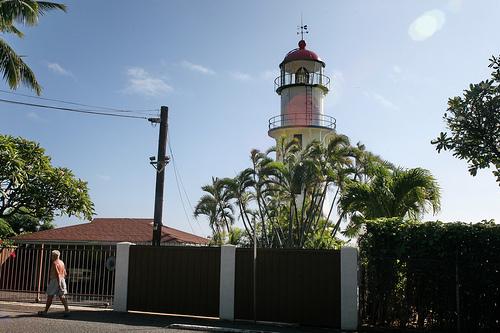Are there vehicles in the picture?
Short answer required. No. Are there clouds in the sky?
Give a very brief answer. Yes. Are there any people in the picture?
Write a very short answer. Yes. Is this building near water?
Quick response, please. No. What kind of building is this?
Answer briefly. Lighthouse. How tall is the lighthouse?
Keep it brief. Tall. 